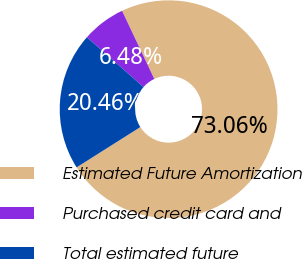<chart> <loc_0><loc_0><loc_500><loc_500><pie_chart><fcel>Estimated Future Amortization<fcel>Purchased credit card and<fcel>Total estimated future<nl><fcel>73.06%<fcel>6.48%<fcel>20.46%<nl></chart> 